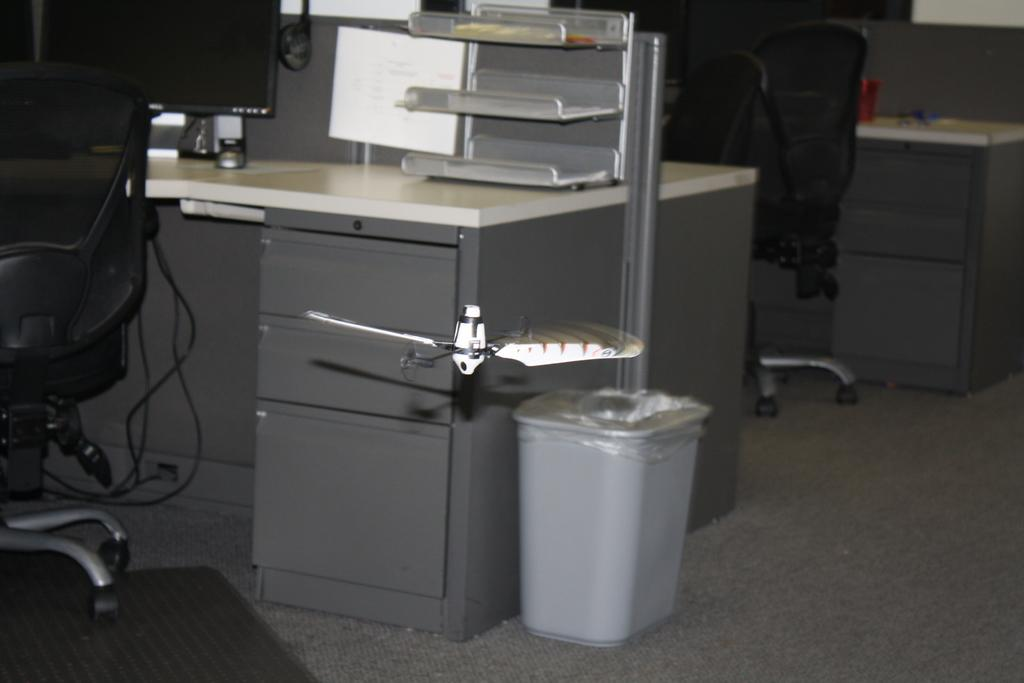What is the main subject of the image? The main subject of the image is a system. Where is the system located? The system is on a table. What type of chair is in the image? There is a black chair in the image. What color is the dustbin in the image? The dustbin is white. Can you describe the background of the image? There is a chair and table in the background of the image. What type of airplane is flying over the system in the image? There is no airplane visible in the image; it only features a system, a table, a black chair, a white dustbin, and a background with a chair and table. 